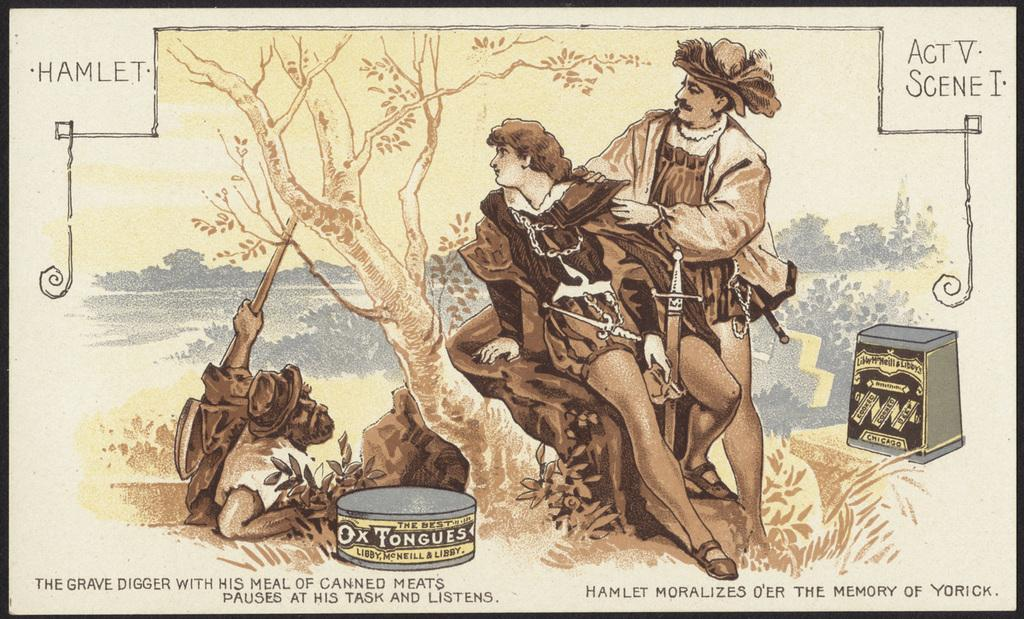What is the main subject of the image? There is a painting in the image. What is depicted in the painting? The painting depicts people and trees. Are there any other objects or elements in the painting? Yes, the painting contains other objects. Is there any text or writing on the image? Yes, there is something written on the image. What type of vacation is being advertised in the painting? There is no vacation being advertised in the painting; it is a work of art depicting people and trees. What type of beef is being served in the painting? There is no beef present in the painting; it depicts people, trees, and other objects. 